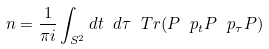Convert formula to latex. <formula><loc_0><loc_0><loc_500><loc_500>n = \frac { 1 } { \pi i } \int _ { S ^ { 2 } } d t \ d \tau \ T r ( P \ p _ { t } P \ p _ { \tau } P )</formula> 